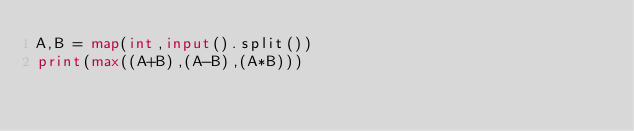Convert code to text. <code><loc_0><loc_0><loc_500><loc_500><_Python_>A,B = map(int,input().split())
print(max((A+B),(A-B),(A*B)))</code> 